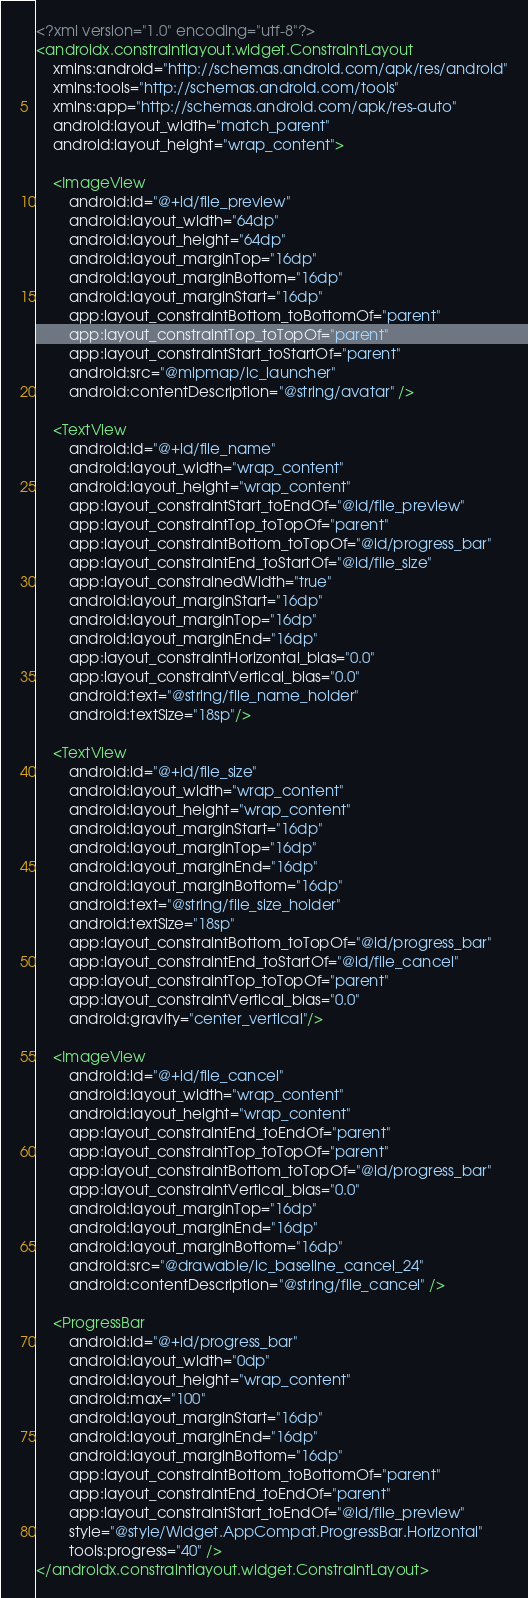<code> <loc_0><loc_0><loc_500><loc_500><_XML_><?xml version="1.0" encoding="utf-8"?>
<androidx.constraintlayout.widget.ConstraintLayout
    xmlns:android="http://schemas.android.com/apk/res/android"
    xmlns:tools="http://schemas.android.com/tools"
    xmlns:app="http://schemas.android.com/apk/res-auto"
    android:layout_width="match_parent"
    android:layout_height="wrap_content">

    <ImageView
        android:id="@+id/file_preview"
        android:layout_width="64dp"
        android:layout_height="64dp"
        android:layout_marginTop="16dp"
        android:layout_marginBottom="16dp"
        android:layout_marginStart="16dp"
        app:layout_constraintBottom_toBottomOf="parent"
        app:layout_constraintTop_toTopOf="parent"
        app:layout_constraintStart_toStartOf="parent"
        android:src="@mipmap/ic_launcher"
        android:contentDescription="@string/avatar" />

    <TextView
        android:id="@+id/file_name"
        android:layout_width="wrap_content"
        android:layout_height="wrap_content"
        app:layout_constraintStart_toEndOf="@id/file_preview"
        app:layout_constraintTop_toTopOf="parent"
        app:layout_constraintBottom_toTopOf="@id/progress_bar"
        app:layout_constraintEnd_toStartOf="@id/file_size"
        app:layout_constrainedWidth="true"
        android:layout_marginStart="16dp"
        android:layout_marginTop="16dp"
        android:layout_marginEnd="16dp"
        app:layout_constraintHorizontal_bias="0.0"
        app:layout_constraintVertical_bias="0.0"
        android:text="@string/file_name_holder"
        android:textSize="18sp"/>

    <TextView
        android:id="@+id/file_size"
        android:layout_width="wrap_content"
        android:layout_height="wrap_content"
        android:layout_marginStart="16dp"
        android:layout_marginTop="16dp"
        android:layout_marginEnd="16dp"
        android:layout_marginBottom="16dp"
        android:text="@string/file_size_holder"
        android:textSize="18sp"
        app:layout_constraintBottom_toTopOf="@id/progress_bar"
        app:layout_constraintEnd_toStartOf="@id/file_cancel"
        app:layout_constraintTop_toTopOf="parent"
        app:layout_constraintVertical_bias="0.0"
        android:gravity="center_vertical"/>

    <ImageView
        android:id="@+id/file_cancel"
        android:layout_width="wrap_content"
        android:layout_height="wrap_content"
        app:layout_constraintEnd_toEndOf="parent"
        app:layout_constraintTop_toTopOf="parent"
        app:layout_constraintBottom_toTopOf="@id/progress_bar"
        app:layout_constraintVertical_bias="0.0"
        android:layout_marginTop="16dp"
        android:layout_marginEnd="16dp"
        android:layout_marginBottom="16dp"
        android:src="@drawable/ic_baseline_cancel_24"
        android:contentDescription="@string/file_cancel" />

    <ProgressBar
        android:id="@+id/progress_bar"
        android:layout_width="0dp"
        android:layout_height="wrap_content"
        android:max="100"
        android:layout_marginStart="16dp"
        android:layout_marginEnd="16dp"
        android:layout_marginBottom="16dp"
        app:layout_constraintBottom_toBottomOf="parent"
        app:layout_constraintEnd_toEndOf="parent"
        app:layout_constraintStart_toEndOf="@id/file_preview"
        style="@style/Widget.AppCompat.ProgressBar.Horizontal"
        tools:progress="40" />
</androidx.constraintlayout.widget.ConstraintLayout>
</code> 